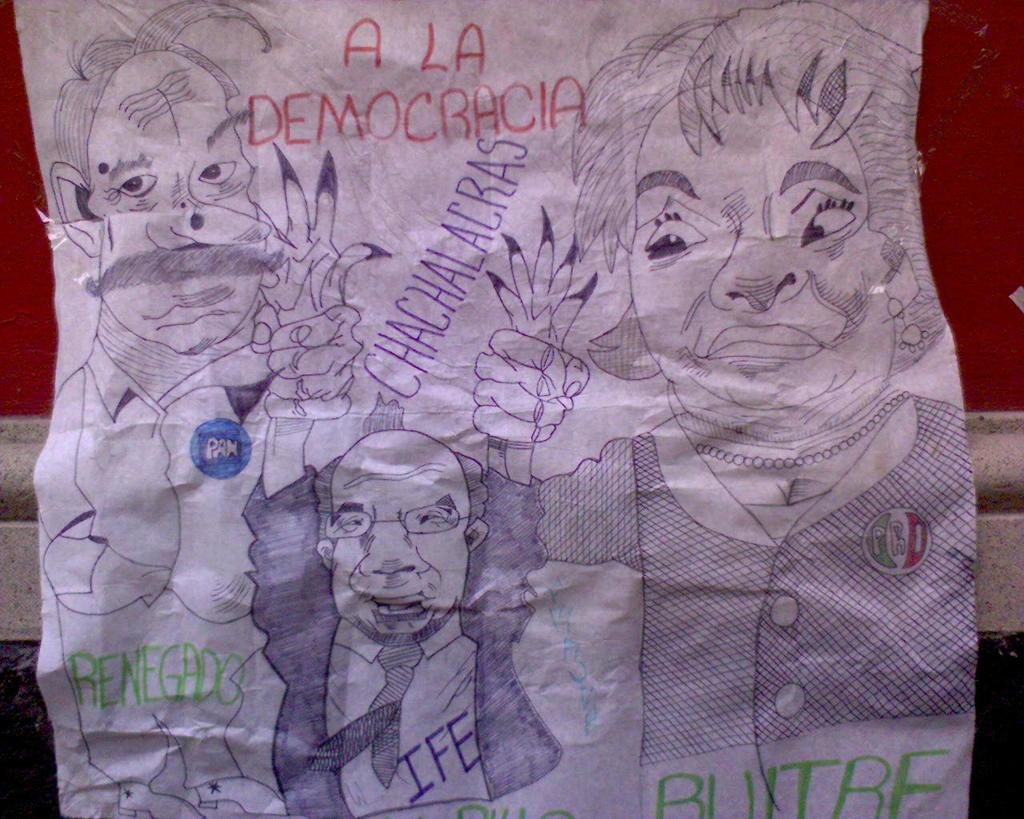What is present on the paper in the image? There are drawings on the paper. What can be seen behind the paper in the image? There is a wall visible behind the paper. What type of seed can be seen growing on the wall in the image? There is no seed or plant growth visible on the wall in the image. 